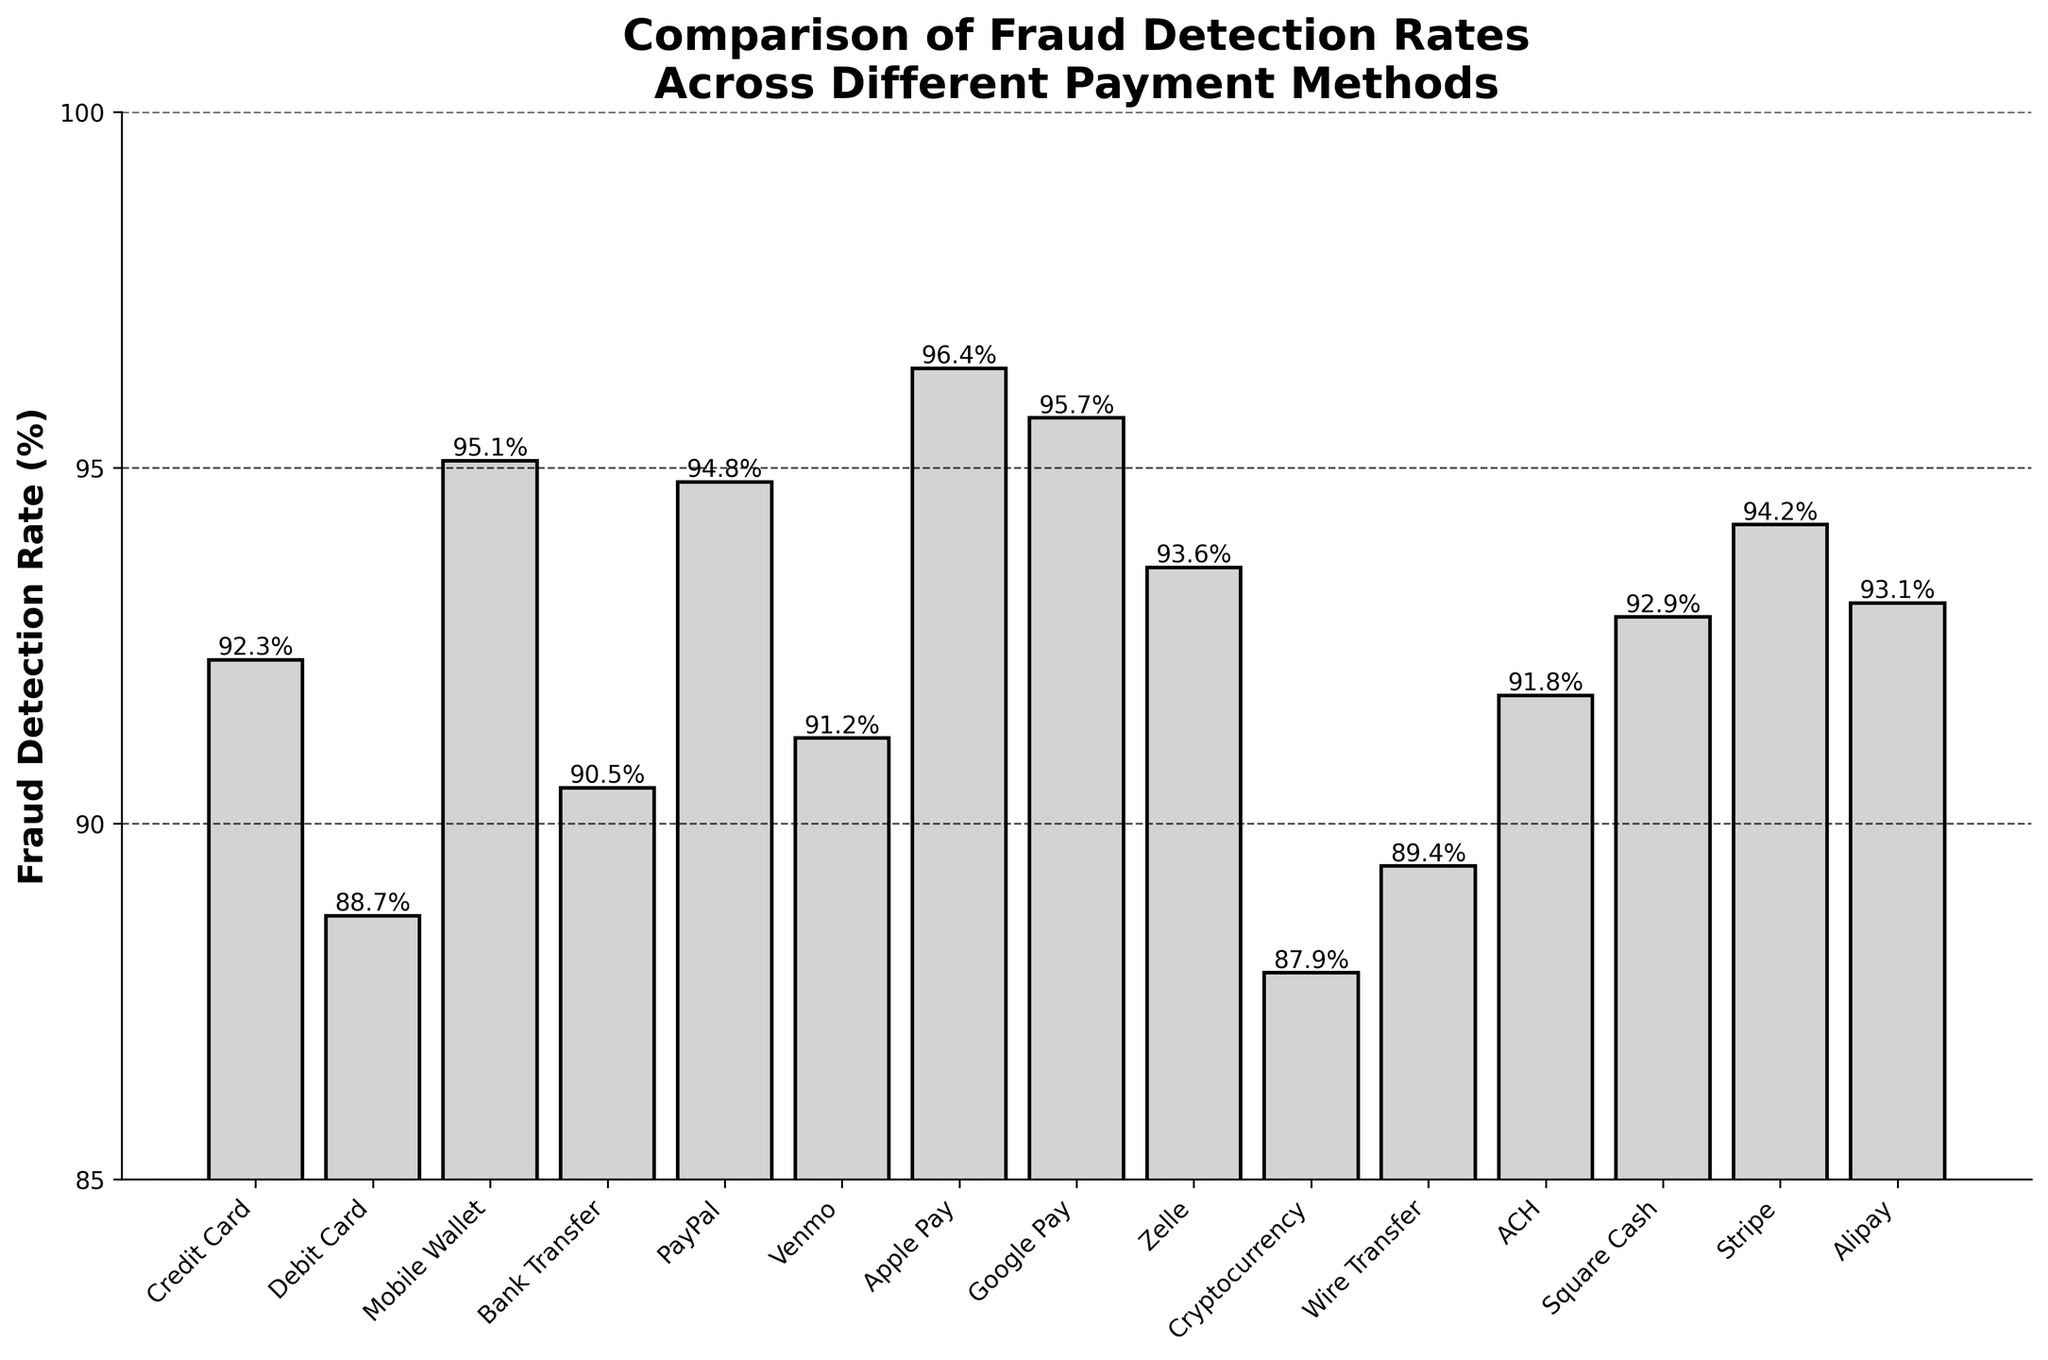What's the payment method with the highest fraud detection rate? To find the payment method with the highest fraud detection rate, locate the bar that reaches the highest point on the y-axis. Look at the label on the x-axis corresponding to this bar.
Answer: Apple Pay What is the difference in fraud detection rate between Google Pay and Cryptocurrency? Locate the bars for Google Pay and Cryptocurrency and note their heights, which are 95.7% and 87.9%, respectively. Subtract the smaller rate from the larger one: 95.7% - 87.9%.
Answer: 7.8% Which payment method has a lower fraud detection rate, Venmo or ACH? Locate the bars for Venmo and ACH and observe their heights. Venmo's rate is 91.2%, and ACH's rate is 91.8%. Compare the two rates to see which is lower.
Answer: Venmo What's the average fraud detection rate of Credit Card, PayPal, and Alipay? Note the fraud detection rates: Credit Card (92.3%), PayPal (94.8%), Alipay (93.1%). Sum them up: 92.3 + 94.8 + 93.1 = 280.2. Then, divide by the number of methods (3): 280.2 / 3.
Answer: 93.4% Does Wire Transfer or Debit Card have a higher fraud detection rate? Locate the bars for Wire Transfer and Debit Card and note their heights: Wire Transfer is 89.4%, and Debit Card is 88.7%. Compare to see which is higher.
Answer: Wire Transfer What's the fraud detection rate range represented in the chart? Identify the smallest and largest fraud detection rates from the chart. The smallest is Cryptocurrency (87.9%), and the largest is Apple Pay (96.4%). Subtract the smallest rate from the largest one: 96.4% - 87.9%.
Answer: 8.5% Which payment method is just below the 95% fraud detection rate? Look for the bar directly below the 95% mark on the y-axis. Note the corresponding payment method. The bar just below 95% is for PayPal (94.8%).
Answer: PayPal How many payment methods have a fraud detection rate of 92% or higher? Identify all bars with heights starting from 92% till the maximum height, count their corresponding payment methods. The methods are: Credit Card, Venmo, Zelle, Square Cash, Stripe, PayPal, Google Pay, Mobile Wallet, Alipay, Apple Pay. Count them up.
Answer: 10 What are the fraud detection rates of the three lowest-performing payment methods? Identify the three bars with the smallest height. These are Debit Card (88.7%), Wire Transfer (89.4%), and Cryptocurrency (87.9%). List their fraud detection rates.
Answer: 88.7%, 89.4%, 87.9% Which payment method has a higher fraud detection rate, bank transfer or Stripe? Compare the heights of the bars for Bank Transfer (90.5%) and Stripe (94.2%) and see which one is taller.
Answer: Stripe 